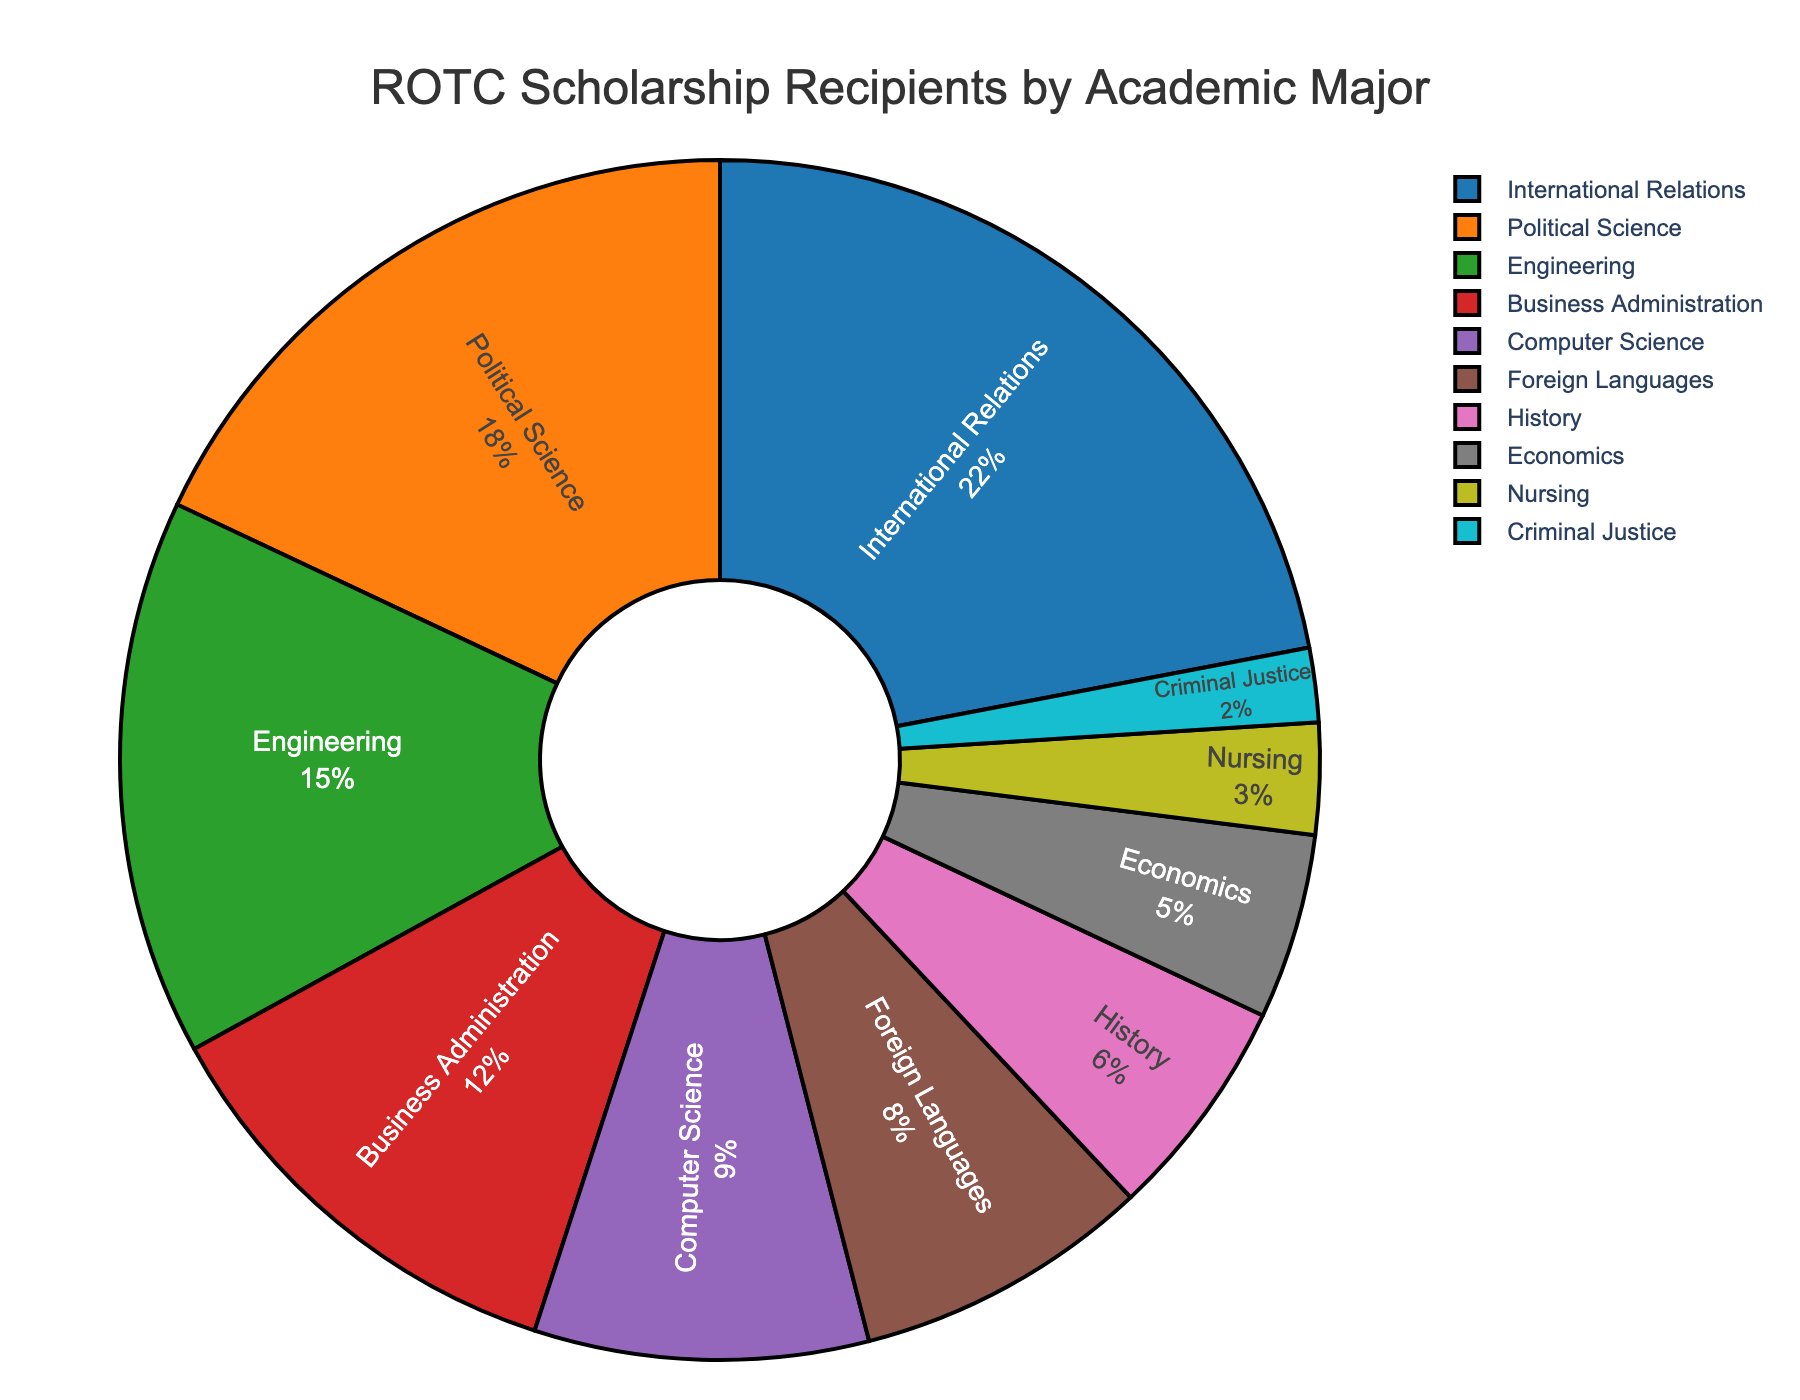Which major has the highest number of ROTC scholarship recipients? According to the pie chart, the major with the largest segment is International Relations.
Answer: International Relations Which major has more scholarship recipients, Engineering or Business Administration? The percentages for Engineering and Business Administration are 15% and 12%, respectively. Since 15% is greater than 12%, Engineering has more scholarship recipients.
Answer: Engineering What is the combined percentage of ROTC scholarship recipients in Political Science and History? The percentage for Political Science is 18% and for History is 6%. Adding these together gives 18% + 6% = 24%.
Answer: 24% How does the percentage of ROTC scholarship recipients in Foreign Languages compare to that in Computer Science? Foreign Languages have 8%, while Computer Science has 9%. Since 9% is greater than 8%, Computer Science has a higher percentage.
Answer: Computer Science What is the difference in percentage between the major with the highest recipients and the major with the lowest recipients? The highest percentage is for International Relations at 22%, and the lowest is for Criminal Justice at 2%. The difference is 22% - 2% = 20%.
Answer: 20% How many majors have a percentage of 10% or more? By examining the chart, the majors with 10% or more are International Relations (22%), Political Science (18%), and Engineering (15%). This amounts to 3 majors.
Answer: 3 What is the average percentage of the top three majors by ROTC scholarship recipients? The top three majors are International Relations (22%), Political Science (18%), and Engineering (15%). The average is calculated by: (22% + 18% + 15%) / 3 = 55% / 3 ≈ 18.33%.
Answer: 18.33% What is the total percentage of ROTC scholarship recipients in majors related to computers and languages together? The relevant percentages are Computer Science (9%) and Foreign Languages (8%). Adding these gives 9% + 8% = 17%.
Answer: 17% Which major lies between History and Business Administration in terms of the percentage of recipients? According to the pie chart, History has 6%, Business Administration has 12%, and Foreign Languages is between them with 8%.
Answer: Foreign Languages 